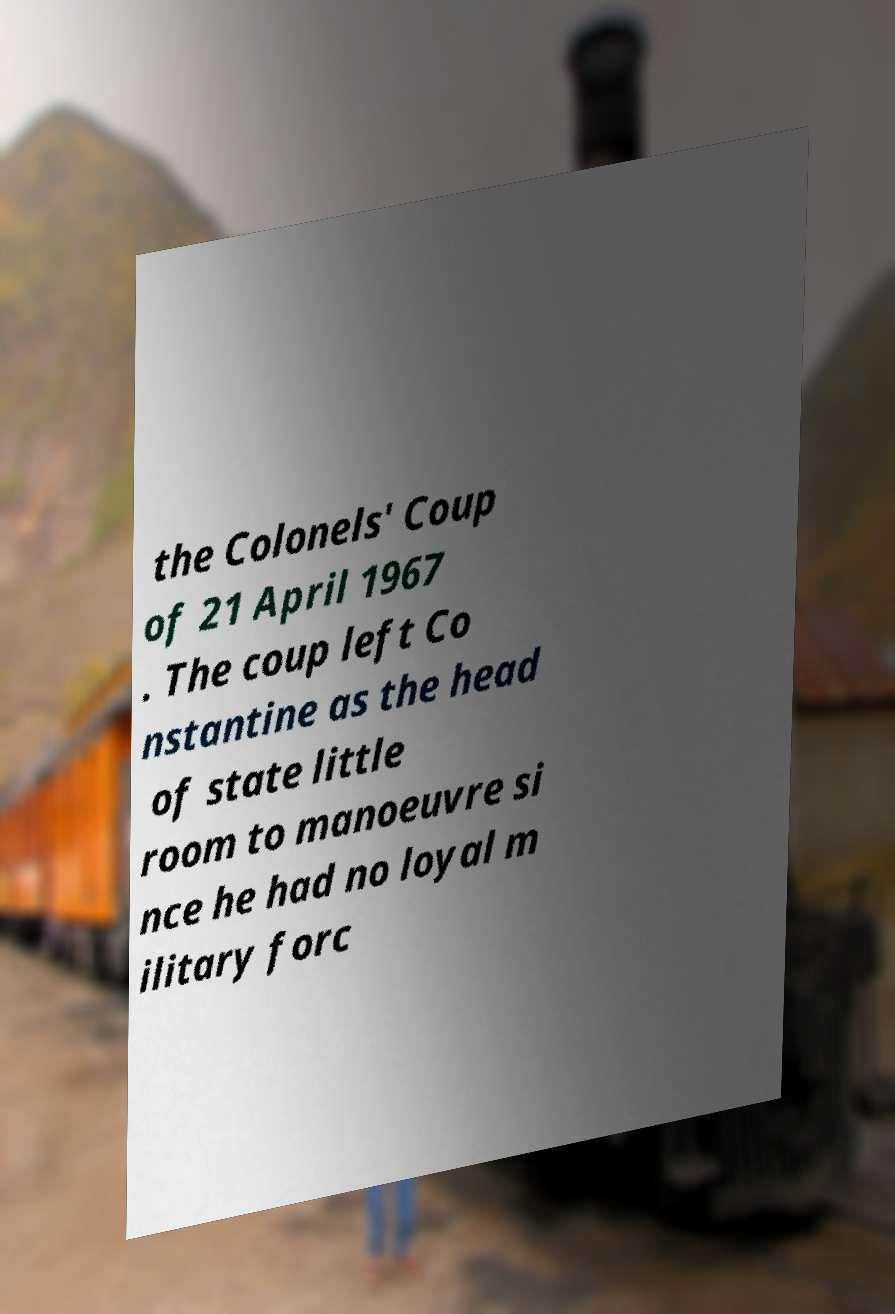Could you assist in decoding the text presented in this image and type it out clearly? the Colonels' Coup of 21 April 1967 . The coup left Co nstantine as the head of state little room to manoeuvre si nce he had no loyal m ilitary forc 